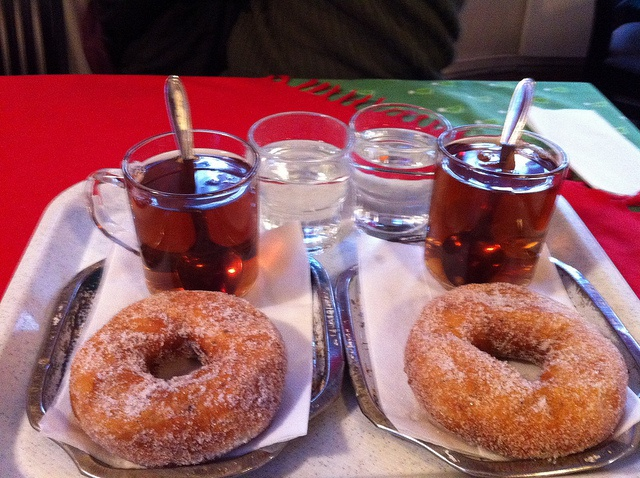Describe the objects in this image and their specific colors. I can see dining table in black, lavender, maroon, lightpink, and brown tones, donut in black, brown, lightpink, and salmon tones, donut in black, brown, and salmon tones, cup in black, maroon, and brown tones, and cup in black, maroon, white, and brown tones in this image. 